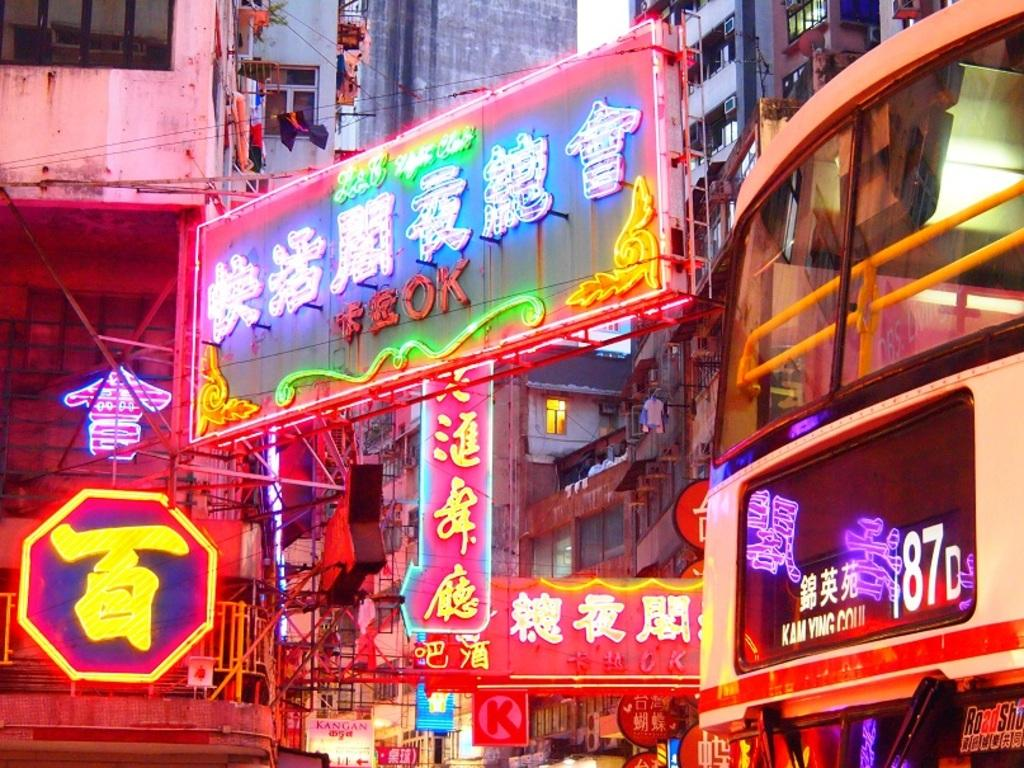What type of structures are present in the picture? There are buildings in the picture. What feature do the buildings have? The buildings have windows. What additional decorations can be seen in the picture? There are banners with lights in the picture. What is the condition of the sky in the picture? The sky is clear in the picture. How many pests can be seen crawling on the buildings in the image? There are no pests visible in the image; only the buildings, windows, banners with lights, and clear sky are present. What type of dog is sitting on the roof of the building in the image? There is no dog present on the roof or anywhere else in the image. 